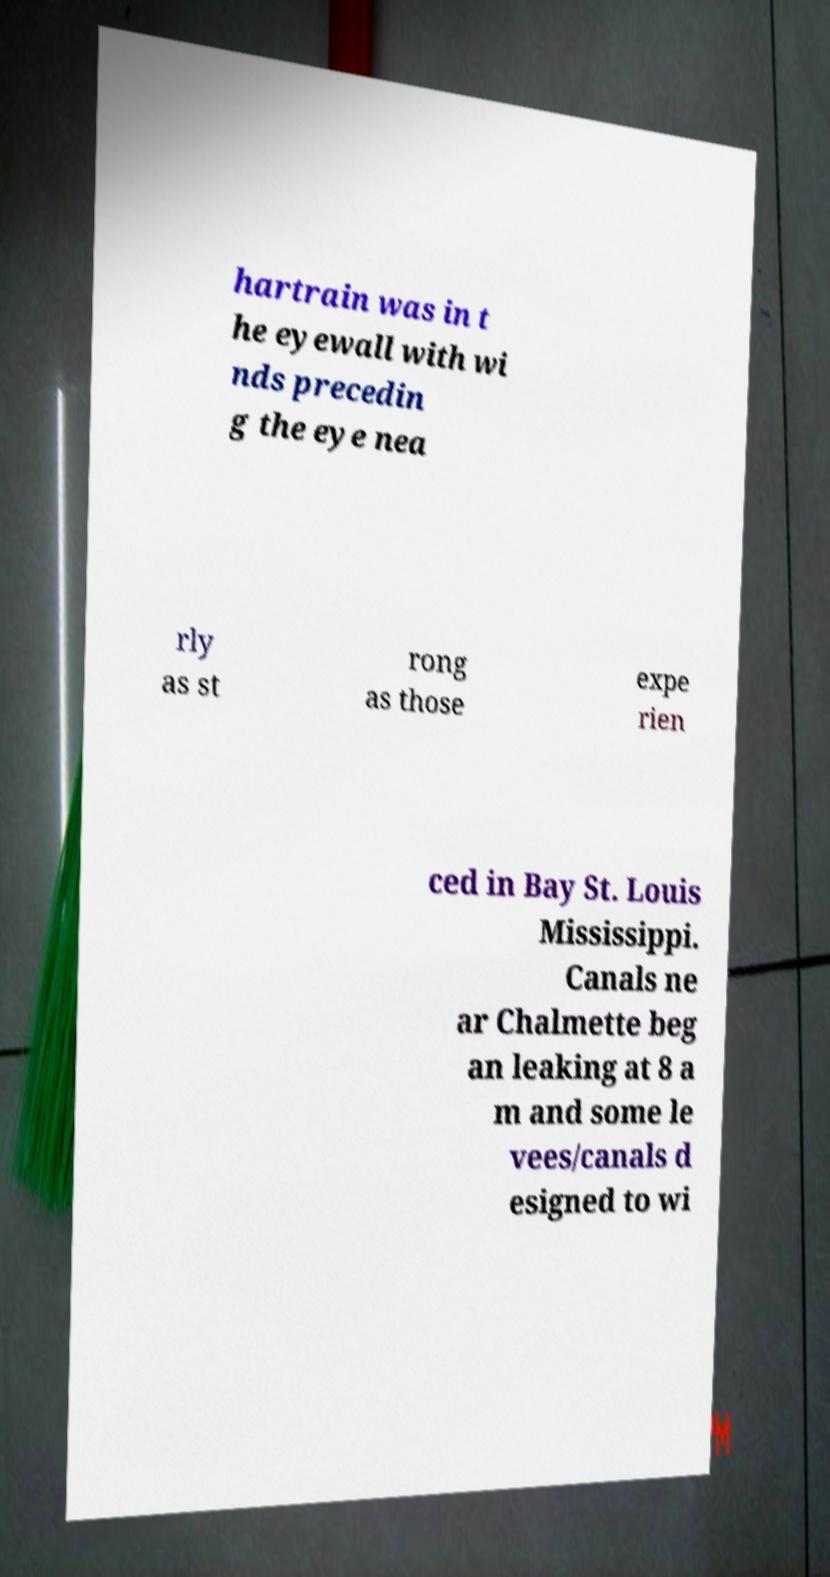I need the written content from this picture converted into text. Can you do that? hartrain was in t he eyewall with wi nds precedin g the eye nea rly as st rong as those expe rien ced in Bay St. Louis Mississippi. Canals ne ar Chalmette beg an leaking at 8 a m and some le vees/canals d esigned to wi 